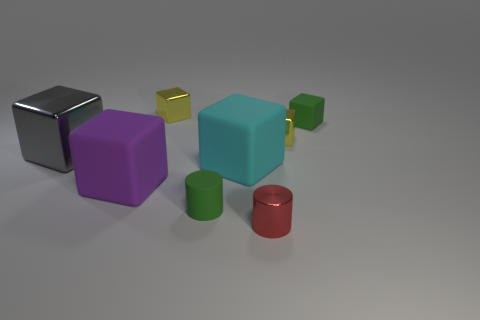How does the lighting affect the mood of the scene? The soft, diffused lighting in the scene casts gentle shadows and gives the image a calm and neutral mood. It allows the colors of the shapes to stand out without creating harsh contrasts, which could be intentional to keep the viewer's focus on the shapes and their surfaces.  Are there any indications of movement or dynamic elements in this scene? There are no clear indications of movement or dynamic elements in this static scene. All shapes are resting on the surface without any signs of motion or interaction. The arrangement looks deliberate and stationary, likely captured at a moment of stillness. 